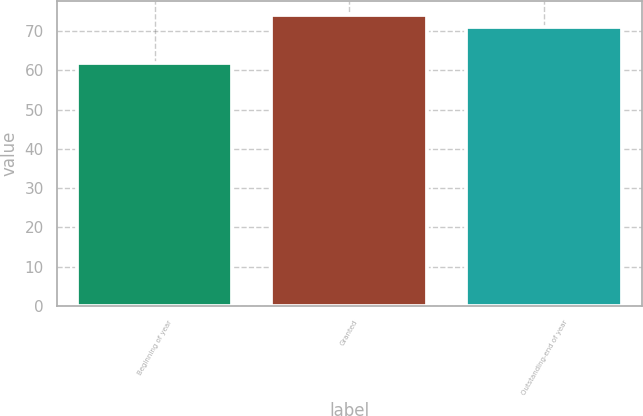Convert chart. <chart><loc_0><loc_0><loc_500><loc_500><bar_chart><fcel>Beginning of year<fcel>Granted<fcel>Outstanding-end of year<nl><fcel>61.94<fcel>74.02<fcel>70.94<nl></chart> 